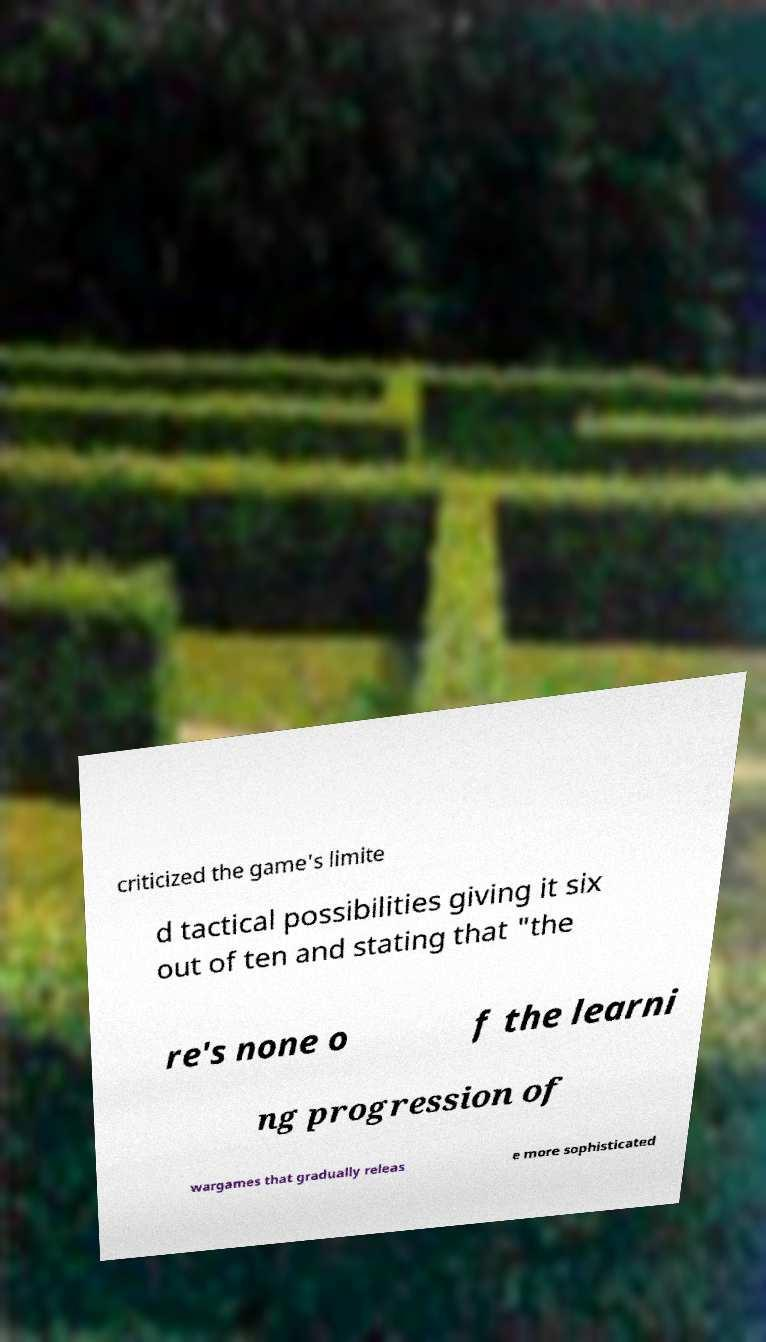Please identify and transcribe the text found in this image. criticized the game's limite d tactical possibilities giving it six out of ten and stating that "the re's none o f the learni ng progression of wargames that gradually releas e more sophisticated 